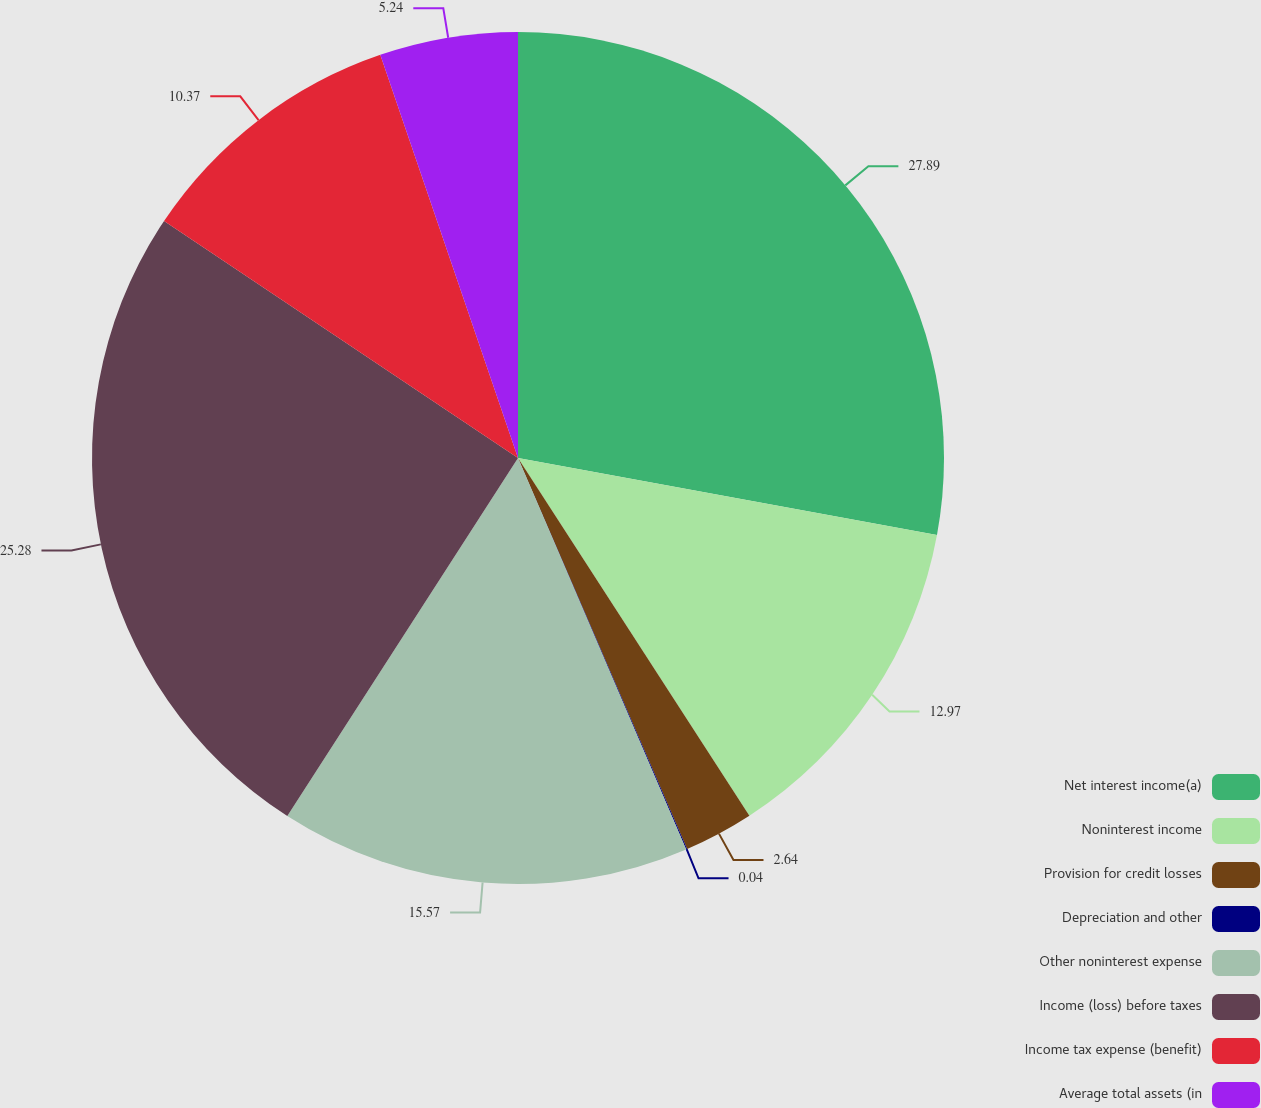Convert chart. <chart><loc_0><loc_0><loc_500><loc_500><pie_chart><fcel>Net interest income(a)<fcel>Noninterest income<fcel>Provision for credit losses<fcel>Depreciation and other<fcel>Other noninterest expense<fcel>Income (loss) before taxes<fcel>Income tax expense (benefit)<fcel>Average total assets (in<nl><fcel>27.9%<fcel>12.97%<fcel>2.64%<fcel>0.04%<fcel>15.57%<fcel>25.29%<fcel>10.37%<fcel>5.24%<nl></chart> 